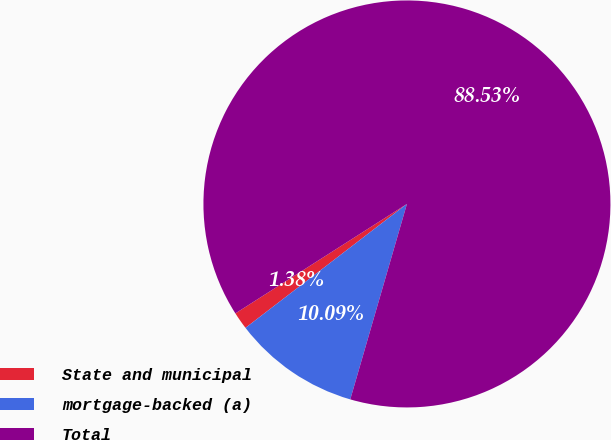Convert chart. <chart><loc_0><loc_0><loc_500><loc_500><pie_chart><fcel>State and municipal<fcel>mortgage-backed (a)<fcel>Total<nl><fcel>1.38%<fcel>10.09%<fcel>88.52%<nl></chart> 